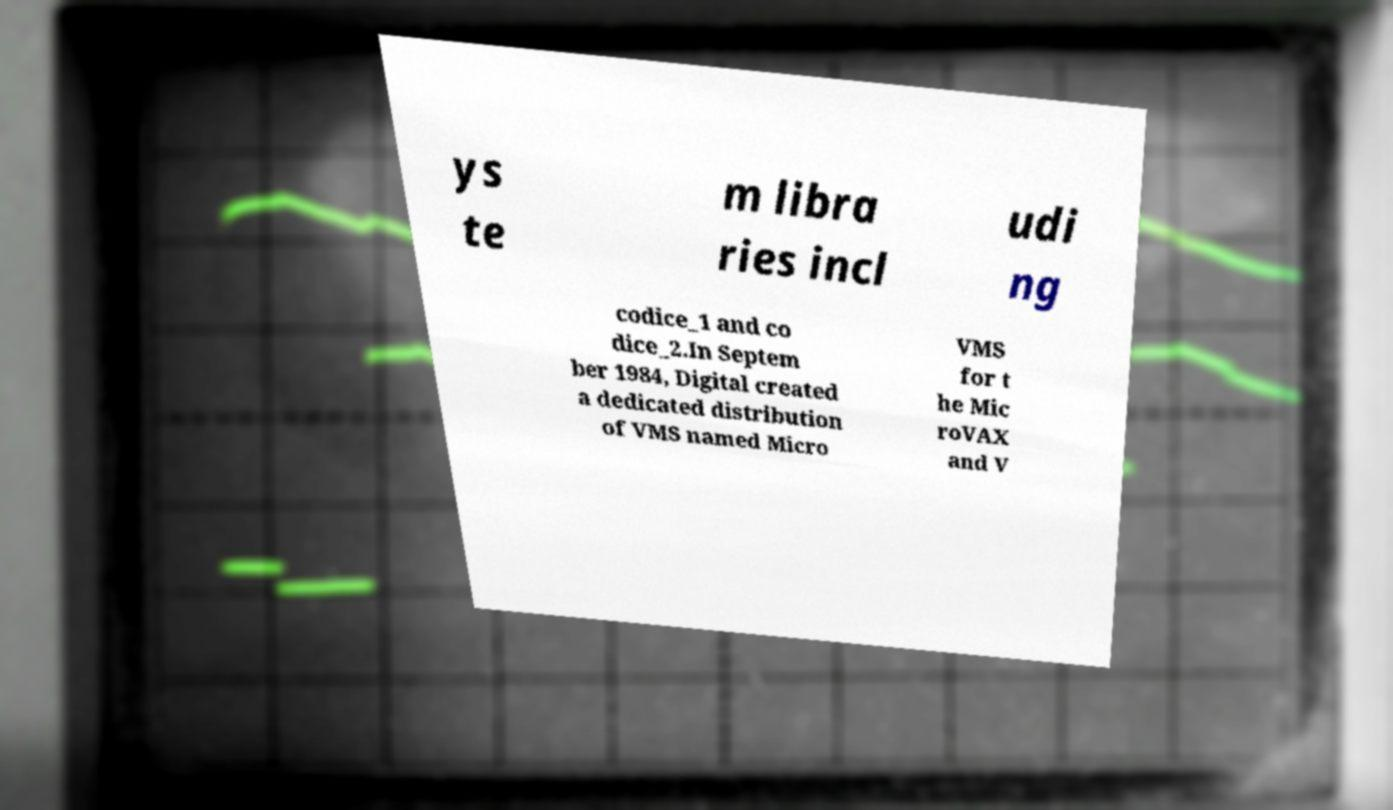Can you accurately transcribe the text from the provided image for me? ys te m libra ries incl udi ng codice_1 and co dice_2.In Septem ber 1984, Digital created a dedicated distribution of VMS named Micro VMS for t he Mic roVAX and V 